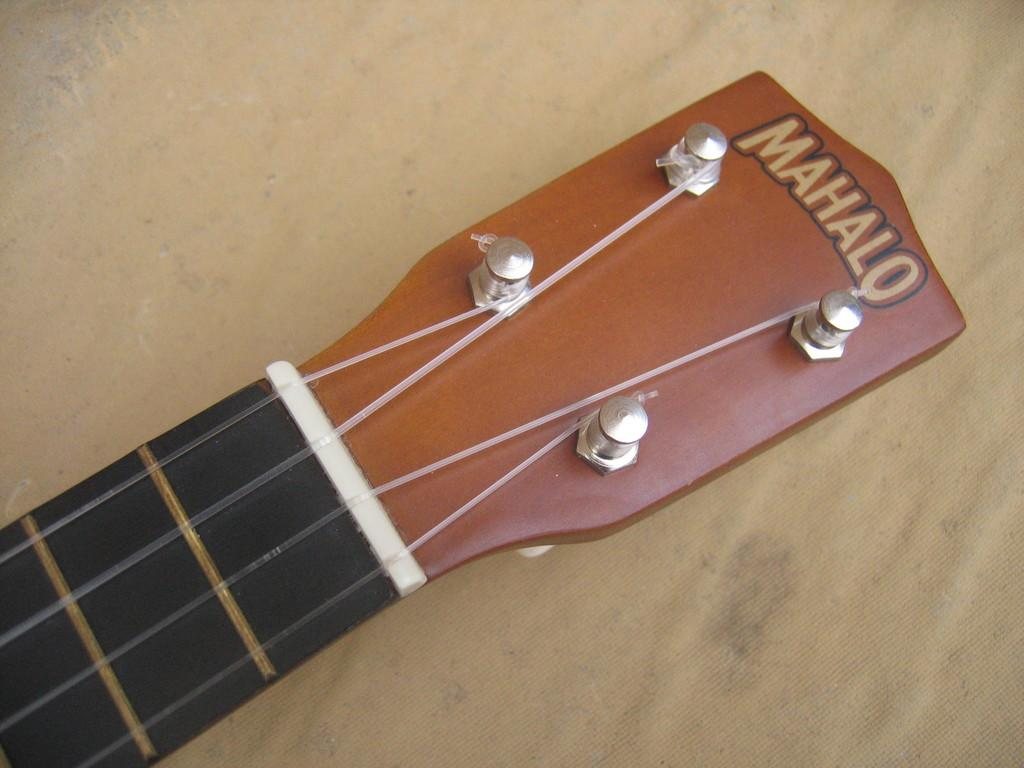What is the main object in the image? The main object in the image is a guitar neck. What part of the guitar is connected to the neck? The headstock is connected to the guitar neck in the image. What are the small, round objects in the image? There are pins in the image. What are the thin, elongated objects in the image? There are strings in the image. Where are all these elements located? All these elements are on a table in the image. How does the guitar taste in the image? The guitar is not an edible object, so it cannot be tasted in the image. 